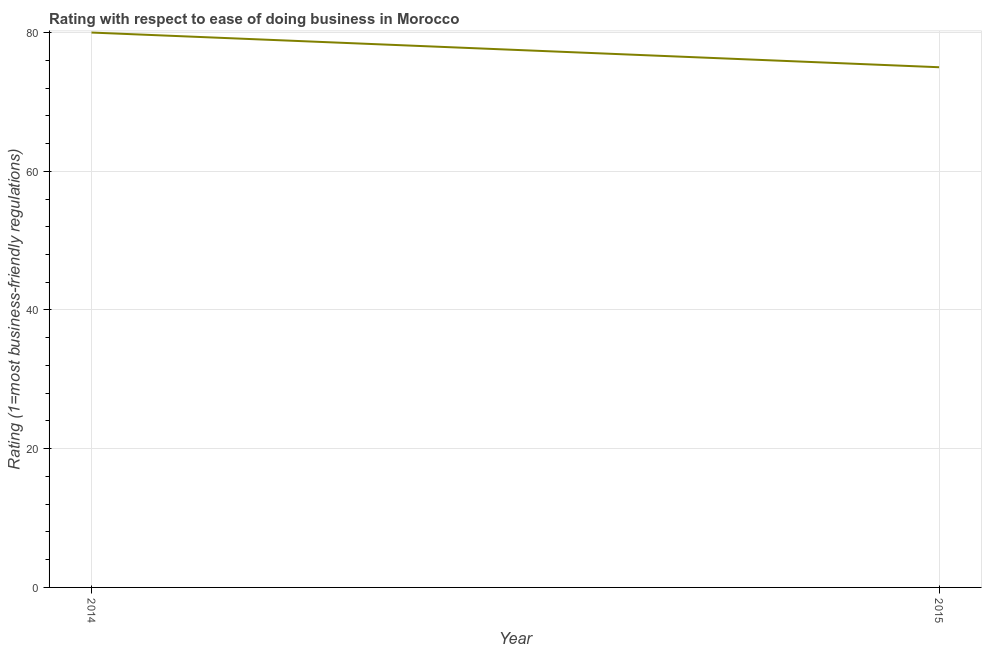What is the ease of doing business index in 2014?
Your response must be concise. 80. Across all years, what is the maximum ease of doing business index?
Provide a short and direct response. 80. Across all years, what is the minimum ease of doing business index?
Your answer should be compact. 75. In which year was the ease of doing business index minimum?
Provide a succinct answer. 2015. What is the sum of the ease of doing business index?
Give a very brief answer. 155. What is the difference between the ease of doing business index in 2014 and 2015?
Your answer should be very brief. 5. What is the average ease of doing business index per year?
Give a very brief answer. 77.5. What is the median ease of doing business index?
Offer a very short reply. 77.5. In how many years, is the ease of doing business index greater than 48 ?
Keep it short and to the point. 2. Do a majority of the years between 2015 and 2014 (inclusive) have ease of doing business index greater than 56 ?
Keep it short and to the point. No. What is the ratio of the ease of doing business index in 2014 to that in 2015?
Keep it short and to the point. 1.07. In how many years, is the ease of doing business index greater than the average ease of doing business index taken over all years?
Your response must be concise. 1. Are the values on the major ticks of Y-axis written in scientific E-notation?
Your answer should be very brief. No. Does the graph contain any zero values?
Keep it short and to the point. No. Does the graph contain grids?
Offer a terse response. Yes. What is the title of the graph?
Give a very brief answer. Rating with respect to ease of doing business in Morocco. What is the label or title of the X-axis?
Make the answer very short. Year. What is the label or title of the Y-axis?
Offer a very short reply. Rating (1=most business-friendly regulations). What is the Rating (1=most business-friendly regulations) of 2014?
Give a very brief answer. 80. What is the ratio of the Rating (1=most business-friendly regulations) in 2014 to that in 2015?
Your answer should be very brief. 1.07. 